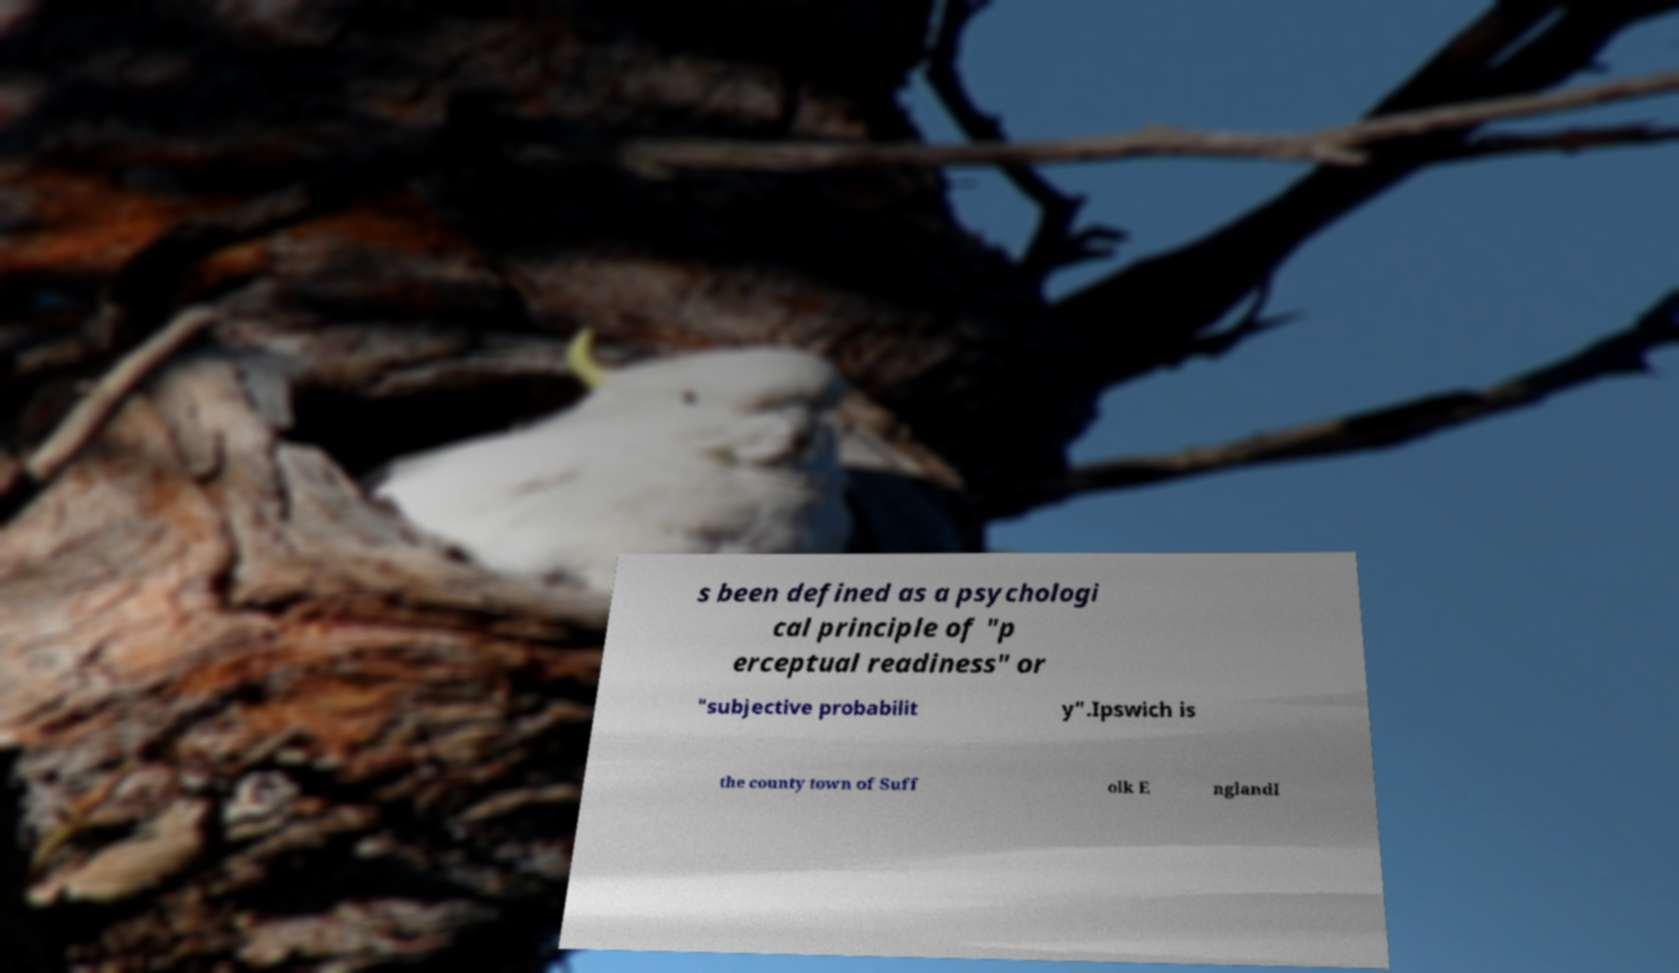For documentation purposes, I need the text within this image transcribed. Could you provide that? s been defined as a psychologi cal principle of "p erceptual readiness" or "subjective probabilit y".Ipswich is the county town of Suff olk E nglandI 